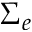Convert formula to latex. <formula><loc_0><loc_0><loc_500><loc_500>\Sigma _ { e }</formula> 